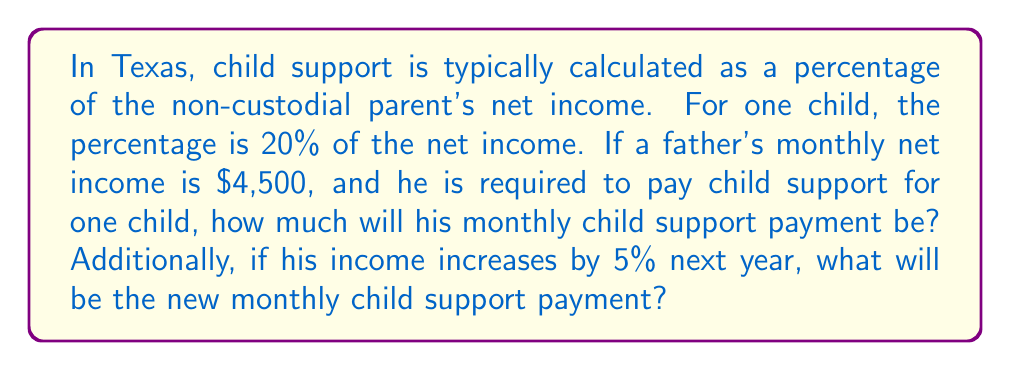Can you answer this question? Let's approach this problem step by step:

1. Calculate the initial child support payment:
   * The percentage for one child is 20% of net income
   * Monthly net income = $4,500
   * Child support payment = $4,500 × 20%
   * $$ \text{Child support} = 4500 \times 0.20 = \$900 $$

2. Calculate the new income after a 5% increase:
   * 5% increase = $4,500 × 5% = $225
   * New monthly net income = $4,500 + $225 = $4,725
   * $$ \text{New income} = 4500 + (4500 \times 0.05) = 4500 + 225 = \$4725 $$

3. Calculate the new child support payment based on the increased income:
   * New child support payment = $4,725 × 20%
   * $$ \text{New child support} = 4725 \times 0.20 = \$945 $$
Answer: The initial monthly child support payment will be $900. After the 5% income increase, the new monthly child support payment will be $945. 